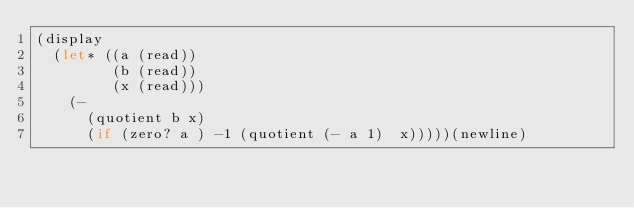<code> <loc_0><loc_0><loc_500><loc_500><_Scheme_>(display
  (let* ((a (read))
         (b (read))
         (x (read)))
    (- 
      (quotient b x)
      (if (zero? a ) -1 (quotient (- a 1)  x)))))(newline)
</code> 